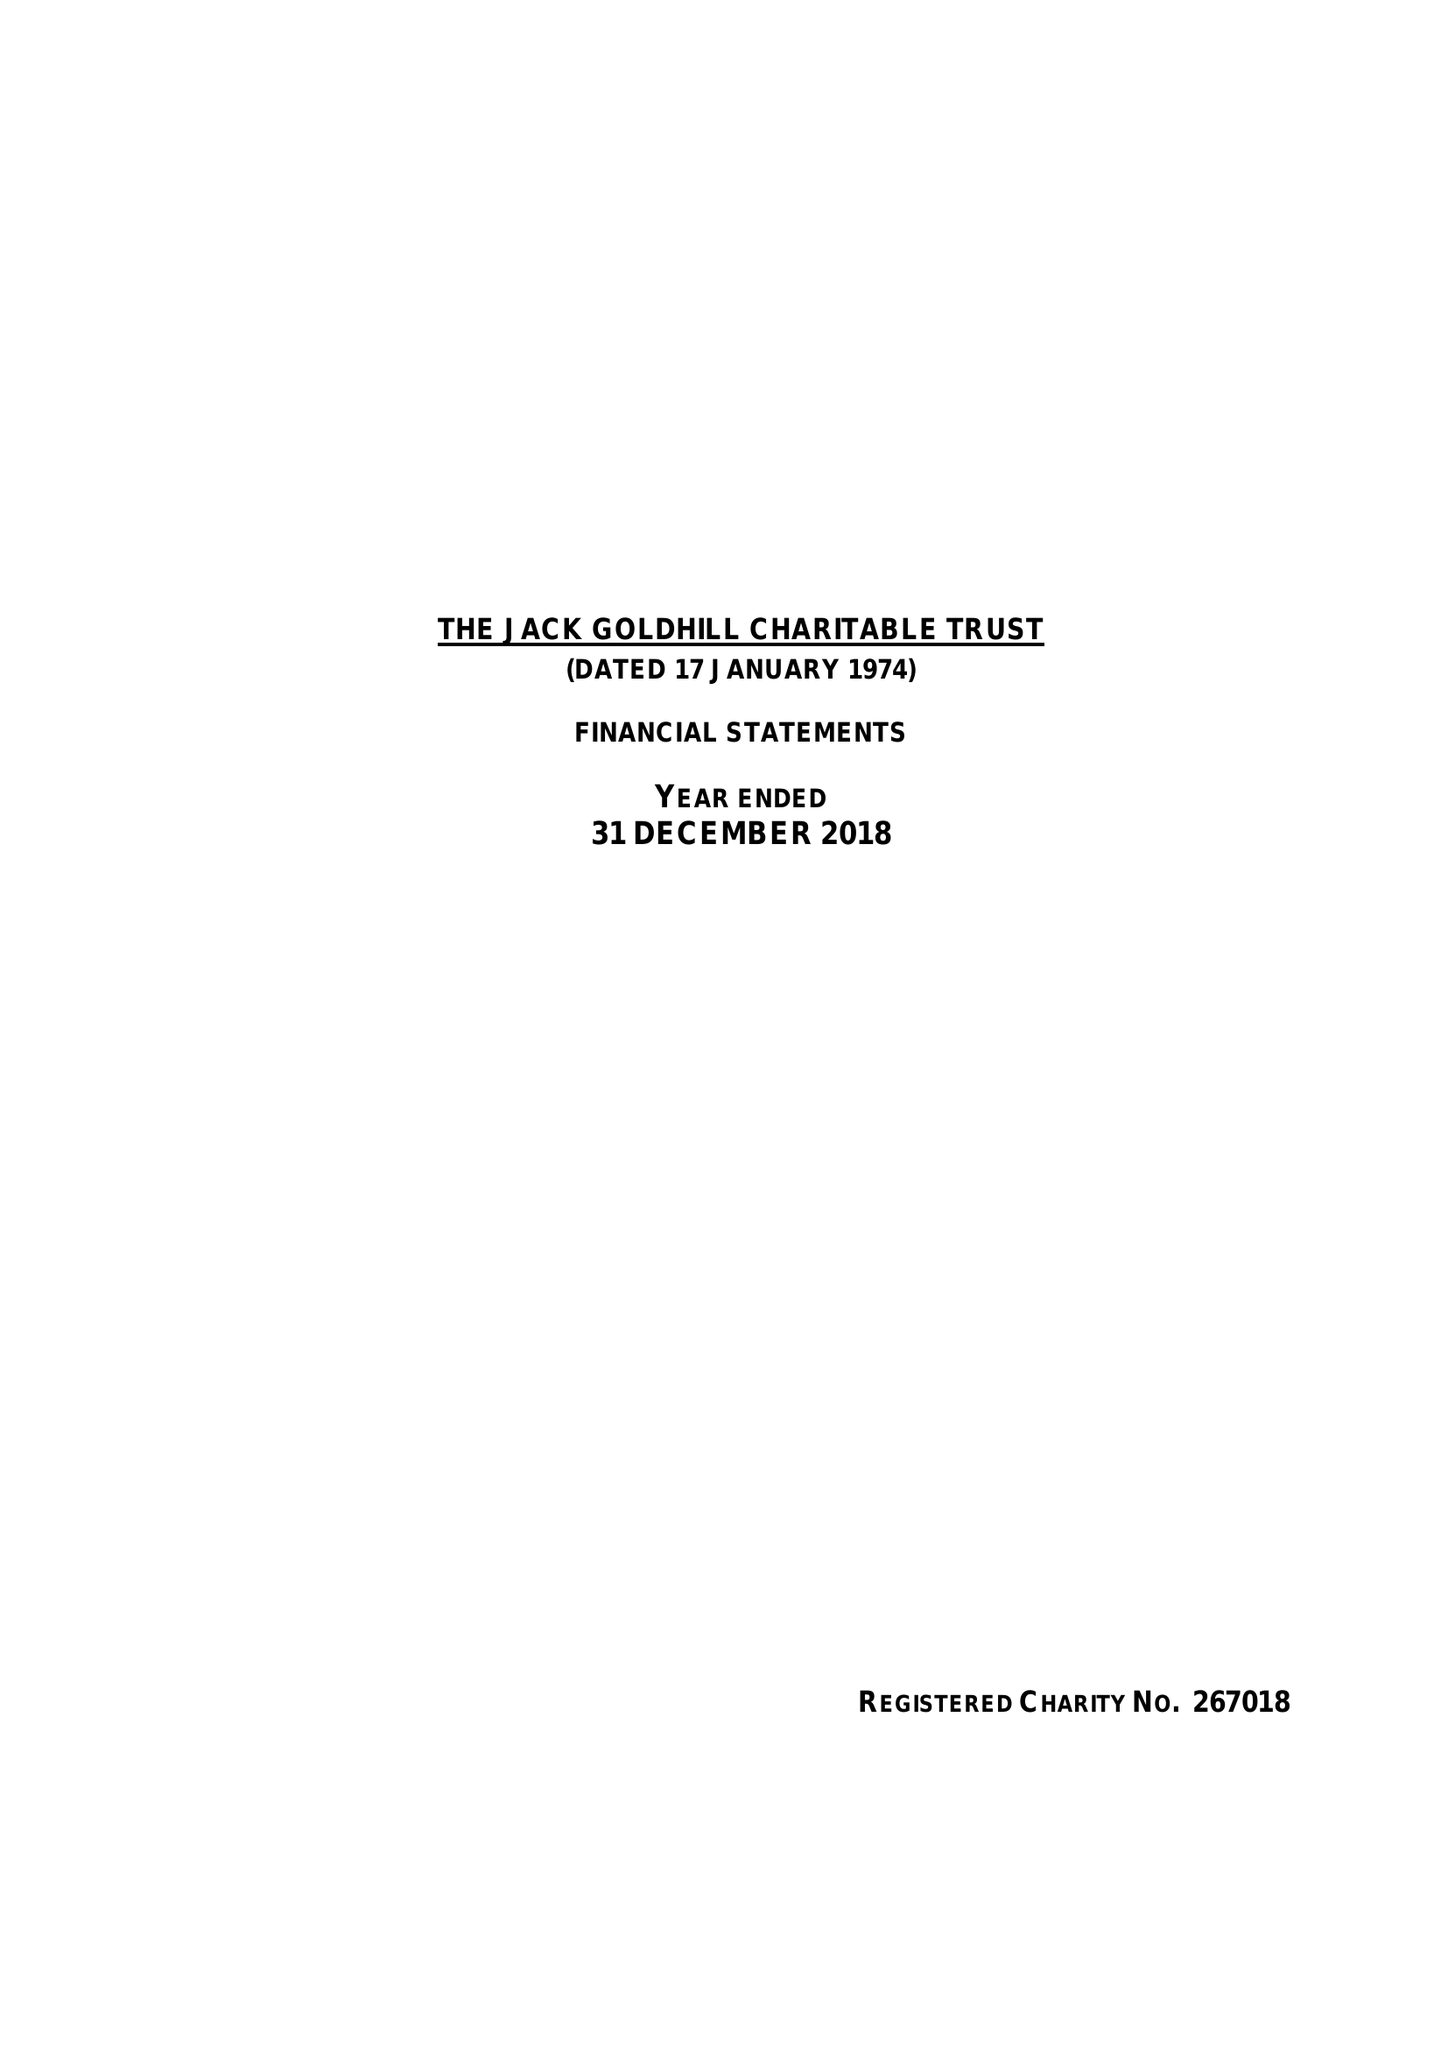What is the value for the spending_annually_in_british_pounds?
Answer the question using a single word or phrase. 115922.00 